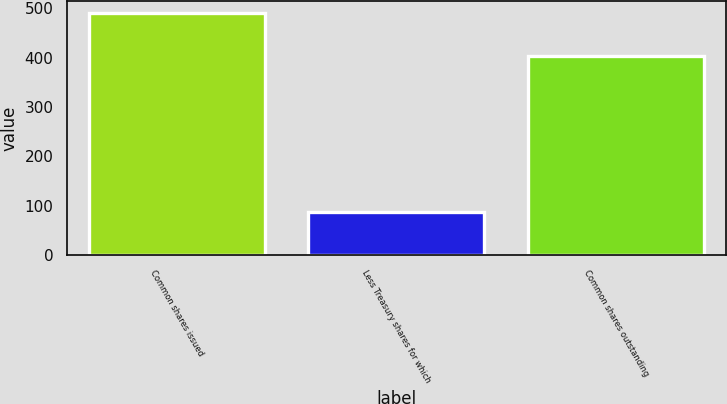<chart> <loc_0><loc_0><loc_500><loc_500><bar_chart><fcel>Common shares issued<fcel>Less Treasury shares for which<fcel>Common shares outstanding<nl><fcel>490.4<fcel>86.6<fcel>403.8<nl></chart> 